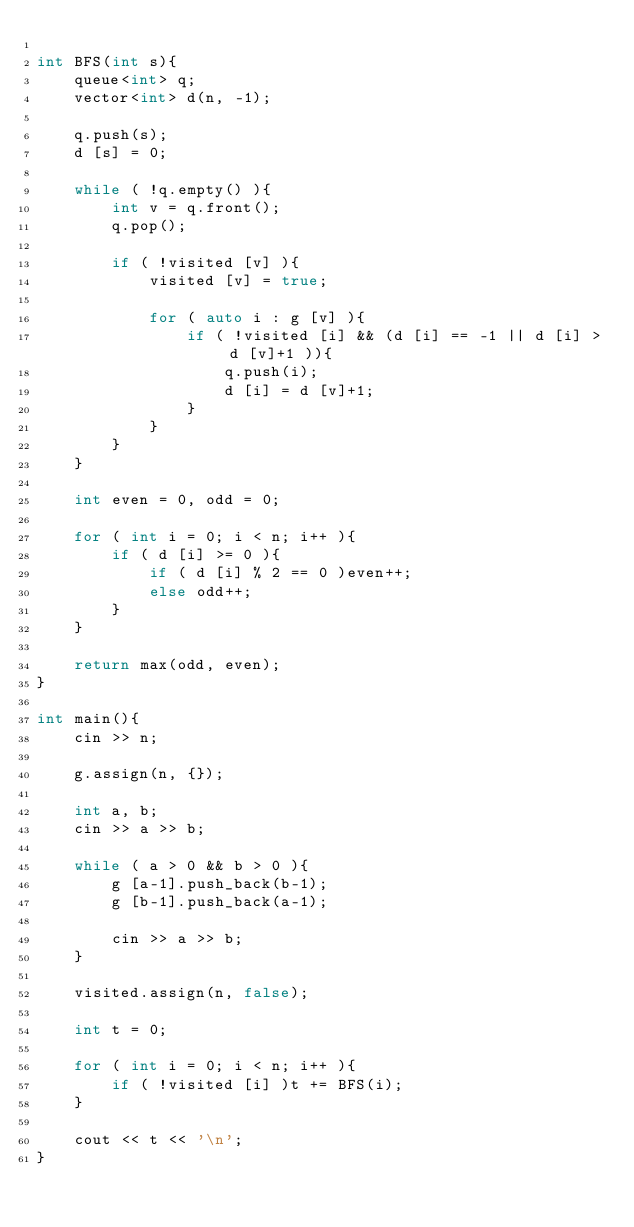Convert code to text. <code><loc_0><loc_0><loc_500><loc_500><_C++_>
int BFS(int s){
	queue<int> q;
	vector<int> d(n, -1);

	q.push(s);
	d [s] = 0;

	while ( !q.empty() ){
		int v = q.front();
		q.pop();

		if ( !visited [v] ){
			visited [v] = true;

			for ( auto i : g [v] ){
				if ( !visited [i] && (d [i] == -1 || d [i] > d [v]+1 )){
					q.push(i);
					d [i] = d [v]+1;
				}
			}
		}
	}

	int even = 0, odd = 0;

	for ( int i = 0; i < n; i++ ){
		if ( d [i] >= 0 ){
			if ( d [i] % 2 == 0 )even++;
			else odd++;
		}
	}

	return max(odd, even);
}

int main(){
	cin >> n;

	g.assign(n, {});

	int a, b;
	cin >> a >> b;

	while ( a > 0 && b > 0 ){
		g [a-1].push_back(b-1);
		g [b-1].push_back(a-1);

		cin >> a >> b;
	}

	visited.assign(n, false);

	int t = 0;

	for ( int i = 0; i < n; i++ ){
		if ( !visited [i] )t += BFS(i);
	}

	cout << t << '\n';
}
</code> 